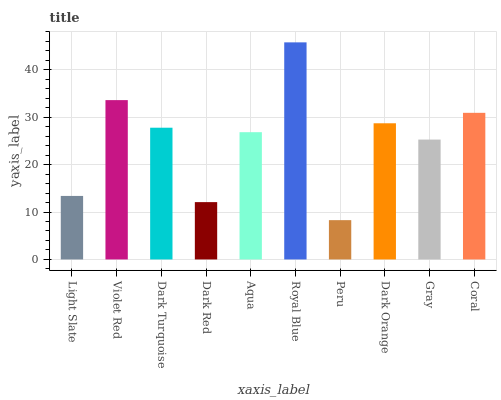Is Peru the minimum?
Answer yes or no. Yes. Is Royal Blue the maximum?
Answer yes or no. Yes. Is Violet Red the minimum?
Answer yes or no. No. Is Violet Red the maximum?
Answer yes or no. No. Is Violet Red greater than Light Slate?
Answer yes or no. Yes. Is Light Slate less than Violet Red?
Answer yes or no. Yes. Is Light Slate greater than Violet Red?
Answer yes or no. No. Is Violet Red less than Light Slate?
Answer yes or no. No. Is Dark Turquoise the high median?
Answer yes or no. Yes. Is Aqua the low median?
Answer yes or no. Yes. Is Peru the high median?
Answer yes or no. No. Is Coral the low median?
Answer yes or no. No. 